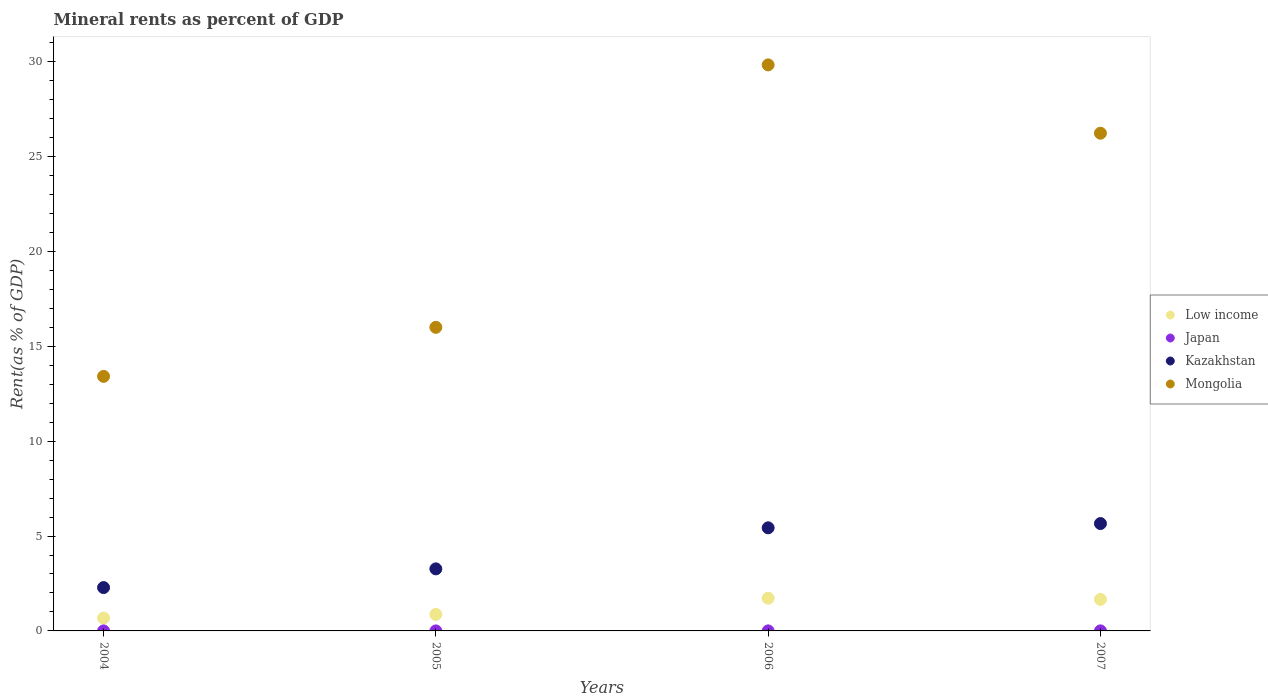How many different coloured dotlines are there?
Keep it short and to the point. 4. Is the number of dotlines equal to the number of legend labels?
Provide a succinct answer. Yes. What is the mineral rent in Kazakhstan in 2005?
Your answer should be very brief. 3.27. Across all years, what is the maximum mineral rent in Mongolia?
Provide a short and direct response. 29.83. Across all years, what is the minimum mineral rent in Japan?
Your answer should be very brief. 0. In which year was the mineral rent in Kazakhstan maximum?
Make the answer very short. 2007. In which year was the mineral rent in Low income minimum?
Offer a terse response. 2004. What is the total mineral rent in Low income in the graph?
Your response must be concise. 4.93. What is the difference between the mineral rent in Japan in 2006 and that in 2007?
Keep it short and to the point. -0. What is the difference between the mineral rent in Low income in 2006 and the mineral rent in Japan in 2007?
Ensure brevity in your answer.  1.72. What is the average mineral rent in Japan per year?
Ensure brevity in your answer.  0. In the year 2005, what is the difference between the mineral rent in Japan and mineral rent in Kazakhstan?
Make the answer very short. -3.27. What is the ratio of the mineral rent in Mongolia in 2005 to that in 2006?
Give a very brief answer. 0.54. What is the difference between the highest and the second highest mineral rent in Mongolia?
Keep it short and to the point. 3.6. What is the difference between the highest and the lowest mineral rent in Low income?
Provide a short and direct response. 1.05. Is the sum of the mineral rent in Low income in 2005 and 2007 greater than the maximum mineral rent in Japan across all years?
Your response must be concise. Yes. Is it the case that in every year, the sum of the mineral rent in Japan and mineral rent in Low income  is greater than the sum of mineral rent in Kazakhstan and mineral rent in Mongolia?
Offer a very short reply. No. Does the mineral rent in Japan monotonically increase over the years?
Provide a short and direct response. Yes. Is the mineral rent in Low income strictly greater than the mineral rent in Mongolia over the years?
Provide a succinct answer. No. Does the graph contain any zero values?
Your answer should be compact. No. Does the graph contain grids?
Your answer should be very brief. No. Where does the legend appear in the graph?
Make the answer very short. Center right. What is the title of the graph?
Offer a terse response. Mineral rents as percent of GDP. Does "Luxembourg" appear as one of the legend labels in the graph?
Give a very brief answer. No. What is the label or title of the X-axis?
Offer a terse response. Years. What is the label or title of the Y-axis?
Give a very brief answer. Rent(as % of GDP). What is the Rent(as % of GDP) in Low income in 2004?
Make the answer very short. 0.68. What is the Rent(as % of GDP) of Japan in 2004?
Offer a very short reply. 0. What is the Rent(as % of GDP) in Kazakhstan in 2004?
Your answer should be very brief. 2.28. What is the Rent(as % of GDP) in Mongolia in 2004?
Provide a succinct answer. 13.41. What is the Rent(as % of GDP) in Low income in 2005?
Make the answer very short. 0.87. What is the Rent(as % of GDP) in Japan in 2005?
Your answer should be very brief. 0. What is the Rent(as % of GDP) of Kazakhstan in 2005?
Give a very brief answer. 3.27. What is the Rent(as % of GDP) of Mongolia in 2005?
Provide a short and direct response. 16. What is the Rent(as % of GDP) in Low income in 2006?
Offer a terse response. 1.72. What is the Rent(as % of GDP) of Japan in 2006?
Offer a very short reply. 0. What is the Rent(as % of GDP) of Kazakhstan in 2006?
Provide a succinct answer. 5.43. What is the Rent(as % of GDP) of Mongolia in 2006?
Offer a terse response. 29.83. What is the Rent(as % of GDP) in Low income in 2007?
Your answer should be compact. 1.66. What is the Rent(as % of GDP) in Japan in 2007?
Offer a very short reply. 0. What is the Rent(as % of GDP) in Kazakhstan in 2007?
Make the answer very short. 5.66. What is the Rent(as % of GDP) in Mongolia in 2007?
Provide a succinct answer. 26.23. Across all years, what is the maximum Rent(as % of GDP) of Low income?
Give a very brief answer. 1.72. Across all years, what is the maximum Rent(as % of GDP) in Japan?
Keep it short and to the point. 0. Across all years, what is the maximum Rent(as % of GDP) in Kazakhstan?
Offer a terse response. 5.66. Across all years, what is the maximum Rent(as % of GDP) of Mongolia?
Provide a succinct answer. 29.83. Across all years, what is the minimum Rent(as % of GDP) in Low income?
Provide a short and direct response. 0.68. Across all years, what is the minimum Rent(as % of GDP) in Japan?
Offer a very short reply. 0. Across all years, what is the minimum Rent(as % of GDP) of Kazakhstan?
Keep it short and to the point. 2.28. Across all years, what is the minimum Rent(as % of GDP) in Mongolia?
Keep it short and to the point. 13.41. What is the total Rent(as % of GDP) of Low income in the graph?
Provide a succinct answer. 4.93. What is the total Rent(as % of GDP) of Japan in the graph?
Ensure brevity in your answer.  0.01. What is the total Rent(as % of GDP) of Kazakhstan in the graph?
Your answer should be compact. 16.64. What is the total Rent(as % of GDP) of Mongolia in the graph?
Offer a very short reply. 85.46. What is the difference between the Rent(as % of GDP) in Low income in 2004 and that in 2005?
Offer a terse response. -0.19. What is the difference between the Rent(as % of GDP) in Japan in 2004 and that in 2005?
Offer a very short reply. -0. What is the difference between the Rent(as % of GDP) in Kazakhstan in 2004 and that in 2005?
Your answer should be compact. -0.99. What is the difference between the Rent(as % of GDP) of Mongolia in 2004 and that in 2005?
Give a very brief answer. -2.58. What is the difference between the Rent(as % of GDP) of Low income in 2004 and that in 2006?
Make the answer very short. -1.05. What is the difference between the Rent(as % of GDP) in Japan in 2004 and that in 2006?
Your response must be concise. -0. What is the difference between the Rent(as % of GDP) of Kazakhstan in 2004 and that in 2006?
Your answer should be very brief. -3.15. What is the difference between the Rent(as % of GDP) of Mongolia in 2004 and that in 2006?
Your answer should be very brief. -16.41. What is the difference between the Rent(as % of GDP) in Low income in 2004 and that in 2007?
Your answer should be compact. -0.98. What is the difference between the Rent(as % of GDP) of Japan in 2004 and that in 2007?
Offer a terse response. -0. What is the difference between the Rent(as % of GDP) in Kazakhstan in 2004 and that in 2007?
Offer a terse response. -3.37. What is the difference between the Rent(as % of GDP) in Mongolia in 2004 and that in 2007?
Ensure brevity in your answer.  -12.81. What is the difference between the Rent(as % of GDP) in Low income in 2005 and that in 2006?
Provide a short and direct response. -0.85. What is the difference between the Rent(as % of GDP) in Japan in 2005 and that in 2006?
Provide a succinct answer. -0. What is the difference between the Rent(as % of GDP) in Kazakhstan in 2005 and that in 2006?
Keep it short and to the point. -2.16. What is the difference between the Rent(as % of GDP) in Mongolia in 2005 and that in 2006?
Offer a very short reply. -13.83. What is the difference between the Rent(as % of GDP) in Low income in 2005 and that in 2007?
Provide a short and direct response. -0.79. What is the difference between the Rent(as % of GDP) in Japan in 2005 and that in 2007?
Provide a short and direct response. -0. What is the difference between the Rent(as % of GDP) of Kazakhstan in 2005 and that in 2007?
Ensure brevity in your answer.  -2.39. What is the difference between the Rent(as % of GDP) in Mongolia in 2005 and that in 2007?
Your answer should be very brief. -10.23. What is the difference between the Rent(as % of GDP) in Low income in 2006 and that in 2007?
Your response must be concise. 0.06. What is the difference between the Rent(as % of GDP) in Japan in 2006 and that in 2007?
Keep it short and to the point. -0. What is the difference between the Rent(as % of GDP) in Kazakhstan in 2006 and that in 2007?
Your response must be concise. -0.22. What is the difference between the Rent(as % of GDP) of Mongolia in 2006 and that in 2007?
Your response must be concise. 3.6. What is the difference between the Rent(as % of GDP) in Low income in 2004 and the Rent(as % of GDP) in Japan in 2005?
Offer a terse response. 0.68. What is the difference between the Rent(as % of GDP) of Low income in 2004 and the Rent(as % of GDP) of Kazakhstan in 2005?
Offer a terse response. -2.59. What is the difference between the Rent(as % of GDP) in Low income in 2004 and the Rent(as % of GDP) in Mongolia in 2005?
Offer a terse response. -15.32. What is the difference between the Rent(as % of GDP) of Japan in 2004 and the Rent(as % of GDP) of Kazakhstan in 2005?
Provide a short and direct response. -3.27. What is the difference between the Rent(as % of GDP) of Japan in 2004 and the Rent(as % of GDP) of Mongolia in 2005?
Offer a terse response. -16. What is the difference between the Rent(as % of GDP) in Kazakhstan in 2004 and the Rent(as % of GDP) in Mongolia in 2005?
Your response must be concise. -13.71. What is the difference between the Rent(as % of GDP) of Low income in 2004 and the Rent(as % of GDP) of Japan in 2006?
Offer a terse response. 0.68. What is the difference between the Rent(as % of GDP) of Low income in 2004 and the Rent(as % of GDP) of Kazakhstan in 2006?
Provide a short and direct response. -4.75. What is the difference between the Rent(as % of GDP) in Low income in 2004 and the Rent(as % of GDP) in Mongolia in 2006?
Provide a short and direct response. -29.15. What is the difference between the Rent(as % of GDP) of Japan in 2004 and the Rent(as % of GDP) of Kazakhstan in 2006?
Your answer should be compact. -5.43. What is the difference between the Rent(as % of GDP) in Japan in 2004 and the Rent(as % of GDP) in Mongolia in 2006?
Keep it short and to the point. -29.83. What is the difference between the Rent(as % of GDP) in Kazakhstan in 2004 and the Rent(as % of GDP) in Mongolia in 2006?
Provide a succinct answer. -27.54. What is the difference between the Rent(as % of GDP) in Low income in 2004 and the Rent(as % of GDP) in Japan in 2007?
Provide a short and direct response. 0.68. What is the difference between the Rent(as % of GDP) of Low income in 2004 and the Rent(as % of GDP) of Kazakhstan in 2007?
Provide a succinct answer. -4.98. What is the difference between the Rent(as % of GDP) of Low income in 2004 and the Rent(as % of GDP) of Mongolia in 2007?
Your response must be concise. -25.55. What is the difference between the Rent(as % of GDP) in Japan in 2004 and the Rent(as % of GDP) in Kazakhstan in 2007?
Ensure brevity in your answer.  -5.66. What is the difference between the Rent(as % of GDP) in Japan in 2004 and the Rent(as % of GDP) in Mongolia in 2007?
Give a very brief answer. -26.23. What is the difference between the Rent(as % of GDP) in Kazakhstan in 2004 and the Rent(as % of GDP) in Mongolia in 2007?
Give a very brief answer. -23.94. What is the difference between the Rent(as % of GDP) of Low income in 2005 and the Rent(as % of GDP) of Japan in 2006?
Your answer should be compact. 0.87. What is the difference between the Rent(as % of GDP) of Low income in 2005 and the Rent(as % of GDP) of Kazakhstan in 2006?
Give a very brief answer. -4.56. What is the difference between the Rent(as % of GDP) of Low income in 2005 and the Rent(as % of GDP) of Mongolia in 2006?
Provide a short and direct response. -28.96. What is the difference between the Rent(as % of GDP) in Japan in 2005 and the Rent(as % of GDP) in Kazakhstan in 2006?
Your response must be concise. -5.43. What is the difference between the Rent(as % of GDP) of Japan in 2005 and the Rent(as % of GDP) of Mongolia in 2006?
Your answer should be very brief. -29.83. What is the difference between the Rent(as % of GDP) of Kazakhstan in 2005 and the Rent(as % of GDP) of Mongolia in 2006?
Ensure brevity in your answer.  -26.56. What is the difference between the Rent(as % of GDP) of Low income in 2005 and the Rent(as % of GDP) of Japan in 2007?
Offer a very short reply. 0.87. What is the difference between the Rent(as % of GDP) in Low income in 2005 and the Rent(as % of GDP) in Kazakhstan in 2007?
Offer a terse response. -4.79. What is the difference between the Rent(as % of GDP) in Low income in 2005 and the Rent(as % of GDP) in Mongolia in 2007?
Your response must be concise. -25.35. What is the difference between the Rent(as % of GDP) of Japan in 2005 and the Rent(as % of GDP) of Kazakhstan in 2007?
Your answer should be compact. -5.66. What is the difference between the Rent(as % of GDP) of Japan in 2005 and the Rent(as % of GDP) of Mongolia in 2007?
Keep it short and to the point. -26.23. What is the difference between the Rent(as % of GDP) in Kazakhstan in 2005 and the Rent(as % of GDP) in Mongolia in 2007?
Your answer should be compact. -22.96. What is the difference between the Rent(as % of GDP) of Low income in 2006 and the Rent(as % of GDP) of Japan in 2007?
Provide a succinct answer. 1.72. What is the difference between the Rent(as % of GDP) in Low income in 2006 and the Rent(as % of GDP) in Kazakhstan in 2007?
Offer a very short reply. -3.93. What is the difference between the Rent(as % of GDP) of Low income in 2006 and the Rent(as % of GDP) of Mongolia in 2007?
Offer a very short reply. -24.5. What is the difference between the Rent(as % of GDP) of Japan in 2006 and the Rent(as % of GDP) of Kazakhstan in 2007?
Your answer should be compact. -5.66. What is the difference between the Rent(as % of GDP) in Japan in 2006 and the Rent(as % of GDP) in Mongolia in 2007?
Provide a succinct answer. -26.22. What is the difference between the Rent(as % of GDP) in Kazakhstan in 2006 and the Rent(as % of GDP) in Mongolia in 2007?
Offer a terse response. -20.79. What is the average Rent(as % of GDP) in Low income per year?
Make the answer very short. 1.23. What is the average Rent(as % of GDP) of Japan per year?
Provide a short and direct response. 0. What is the average Rent(as % of GDP) of Kazakhstan per year?
Give a very brief answer. 4.16. What is the average Rent(as % of GDP) in Mongolia per year?
Ensure brevity in your answer.  21.37. In the year 2004, what is the difference between the Rent(as % of GDP) in Low income and Rent(as % of GDP) in Japan?
Provide a succinct answer. 0.68. In the year 2004, what is the difference between the Rent(as % of GDP) of Low income and Rent(as % of GDP) of Kazakhstan?
Provide a succinct answer. -1.61. In the year 2004, what is the difference between the Rent(as % of GDP) in Low income and Rent(as % of GDP) in Mongolia?
Ensure brevity in your answer.  -12.74. In the year 2004, what is the difference between the Rent(as % of GDP) in Japan and Rent(as % of GDP) in Kazakhstan?
Provide a succinct answer. -2.28. In the year 2004, what is the difference between the Rent(as % of GDP) in Japan and Rent(as % of GDP) in Mongolia?
Provide a succinct answer. -13.41. In the year 2004, what is the difference between the Rent(as % of GDP) in Kazakhstan and Rent(as % of GDP) in Mongolia?
Make the answer very short. -11.13. In the year 2005, what is the difference between the Rent(as % of GDP) of Low income and Rent(as % of GDP) of Japan?
Your answer should be very brief. 0.87. In the year 2005, what is the difference between the Rent(as % of GDP) in Low income and Rent(as % of GDP) in Kazakhstan?
Provide a short and direct response. -2.4. In the year 2005, what is the difference between the Rent(as % of GDP) of Low income and Rent(as % of GDP) of Mongolia?
Ensure brevity in your answer.  -15.13. In the year 2005, what is the difference between the Rent(as % of GDP) in Japan and Rent(as % of GDP) in Kazakhstan?
Provide a short and direct response. -3.27. In the year 2005, what is the difference between the Rent(as % of GDP) of Japan and Rent(as % of GDP) of Mongolia?
Ensure brevity in your answer.  -16. In the year 2005, what is the difference between the Rent(as % of GDP) in Kazakhstan and Rent(as % of GDP) in Mongolia?
Provide a short and direct response. -12.73. In the year 2006, what is the difference between the Rent(as % of GDP) in Low income and Rent(as % of GDP) in Japan?
Make the answer very short. 1.72. In the year 2006, what is the difference between the Rent(as % of GDP) of Low income and Rent(as % of GDP) of Kazakhstan?
Your answer should be very brief. -3.71. In the year 2006, what is the difference between the Rent(as % of GDP) in Low income and Rent(as % of GDP) in Mongolia?
Make the answer very short. -28.1. In the year 2006, what is the difference between the Rent(as % of GDP) in Japan and Rent(as % of GDP) in Kazakhstan?
Your answer should be compact. -5.43. In the year 2006, what is the difference between the Rent(as % of GDP) in Japan and Rent(as % of GDP) in Mongolia?
Offer a terse response. -29.82. In the year 2006, what is the difference between the Rent(as % of GDP) in Kazakhstan and Rent(as % of GDP) in Mongolia?
Ensure brevity in your answer.  -24.39. In the year 2007, what is the difference between the Rent(as % of GDP) in Low income and Rent(as % of GDP) in Japan?
Your answer should be very brief. 1.66. In the year 2007, what is the difference between the Rent(as % of GDP) of Low income and Rent(as % of GDP) of Kazakhstan?
Give a very brief answer. -4. In the year 2007, what is the difference between the Rent(as % of GDP) in Low income and Rent(as % of GDP) in Mongolia?
Your response must be concise. -24.56. In the year 2007, what is the difference between the Rent(as % of GDP) of Japan and Rent(as % of GDP) of Kazakhstan?
Give a very brief answer. -5.66. In the year 2007, what is the difference between the Rent(as % of GDP) in Japan and Rent(as % of GDP) in Mongolia?
Your response must be concise. -26.22. In the year 2007, what is the difference between the Rent(as % of GDP) in Kazakhstan and Rent(as % of GDP) in Mongolia?
Give a very brief answer. -20.57. What is the ratio of the Rent(as % of GDP) of Low income in 2004 to that in 2005?
Your answer should be very brief. 0.78. What is the ratio of the Rent(as % of GDP) in Japan in 2004 to that in 2005?
Provide a succinct answer. 0.75. What is the ratio of the Rent(as % of GDP) in Kazakhstan in 2004 to that in 2005?
Make the answer very short. 0.7. What is the ratio of the Rent(as % of GDP) of Mongolia in 2004 to that in 2005?
Offer a very short reply. 0.84. What is the ratio of the Rent(as % of GDP) of Low income in 2004 to that in 2006?
Offer a terse response. 0.39. What is the ratio of the Rent(as % of GDP) in Japan in 2004 to that in 2006?
Offer a terse response. 0.25. What is the ratio of the Rent(as % of GDP) of Kazakhstan in 2004 to that in 2006?
Make the answer very short. 0.42. What is the ratio of the Rent(as % of GDP) in Mongolia in 2004 to that in 2006?
Offer a very short reply. 0.45. What is the ratio of the Rent(as % of GDP) in Low income in 2004 to that in 2007?
Your response must be concise. 0.41. What is the ratio of the Rent(as % of GDP) in Japan in 2004 to that in 2007?
Offer a terse response. 0.24. What is the ratio of the Rent(as % of GDP) of Kazakhstan in 2004 to that in 2007?
Your answer should be very brief. 0.4. What is the ratio of the Rent(as % of GDP) of Mongolia in 2004 to that in 2007?
Keep it short and to the point. 0.51. What is the ratio of the Rent(as % of GDP) of Low income in 2005 to that in 2006?
Make the answer very short. 0.51. What is the ratio of the Rent(as % of GDP) of Japan in 2005 to that in 2006?
Make the answer very short. 0.34. What is the ratio of the Rent(as % of GDP) of Kazakhstan in 2005 to that in 2006?
Provide a succinct answer. 0.6. What is the ratio of the Rent(as % of GDP) of Mongolia in 2005 to that in 2006?
Your response must be concise. 0.54. What is the ratio of the Rent(as % of GDP) in Low income in 2005 to that in 2007?
Provide a short and direct response. 0.52. What is the ratio of the Rent(as % of GDP) in Japan in 2005 to that in 2007?
Your answer should be compact. 0.32. What is the ratio of the Rent(as % of GDP) of Kazakhstan in 2005 to that in 2007?
Offer a very short reply. 0.58. What is the ratio of the Rent(as % of GDP) in Mongolia in 2005 to that in 2007?
Provide a succinct answer. 0.61. What is the ratio of the Rent(as % of GDP) of Low income in 2006 to that in 2007?
Provide a succinct answer. 1.04. What is the ratio of the Rent(as % of GDP) in Japan in 2006 to that in 2007?
Your answer should be very brief. 0.95. What is the ratio of the Rent(as % of GDP) of Kazakhstan in 2006 to that in 2007?
Make the answer very short. 0.96. What is the ratio of the Rent(as % of GDP) of Mongolia in 2006 to that in 2007?
Your answer should be compact. 1.14. What is the difference between the highest and the second highest Rent(as % of GDP) in Low income?
Your response must be concise. 0.06. What is the difference between the highest and the second highest Rent(as % of GDP) in Kazakhstan?
Your response must be concise. 0.22. What is the difference between the highest and the second highest Rent(as % of GDP) of Mongolia?
Keep it short and to the point. 3.6. What is the difference between the highest and the lowest Rent(as % of GDP) in Low income?
Provide a succinct answer. 1.05. What is the difference between the highest and the lowest Rent(as % of GDP) of Japan?
Offer a very short reply. 0. What is the difference between the highest and the lowest Rent(as % of GDP) of Kazakhstan?
Keep it short and to the point. 3.37. What is the difference between the highest and the lowest Rent(as % of GDP) of Mongolia?
Ensure brevity in your answer.  16.41. 